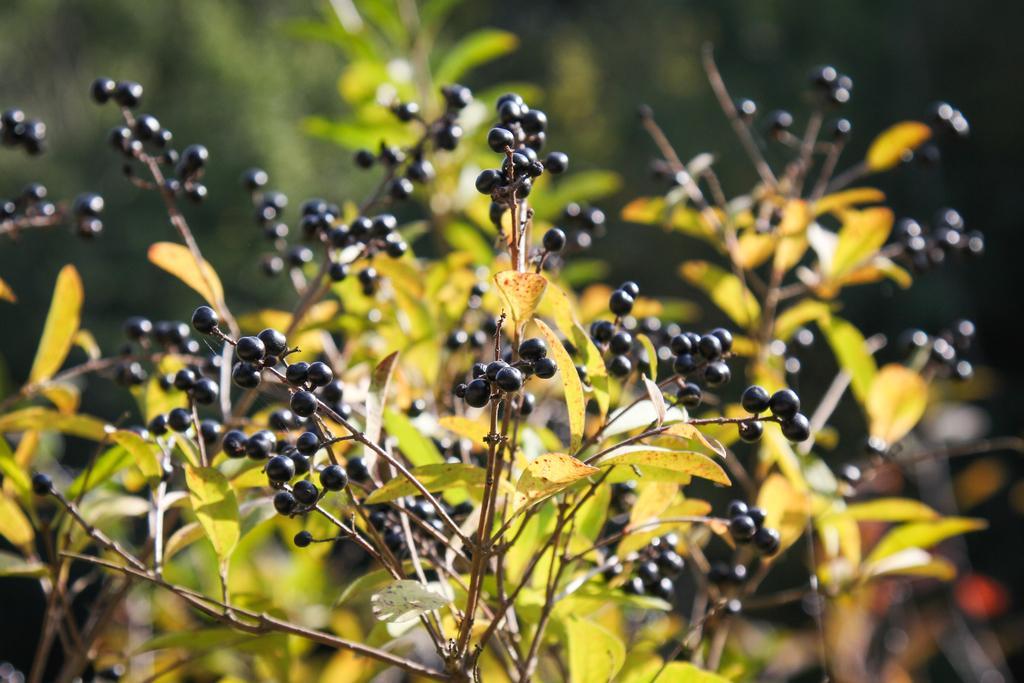Please provide a concise description of this image. In this image we can see the fruits with stem and leaves. 